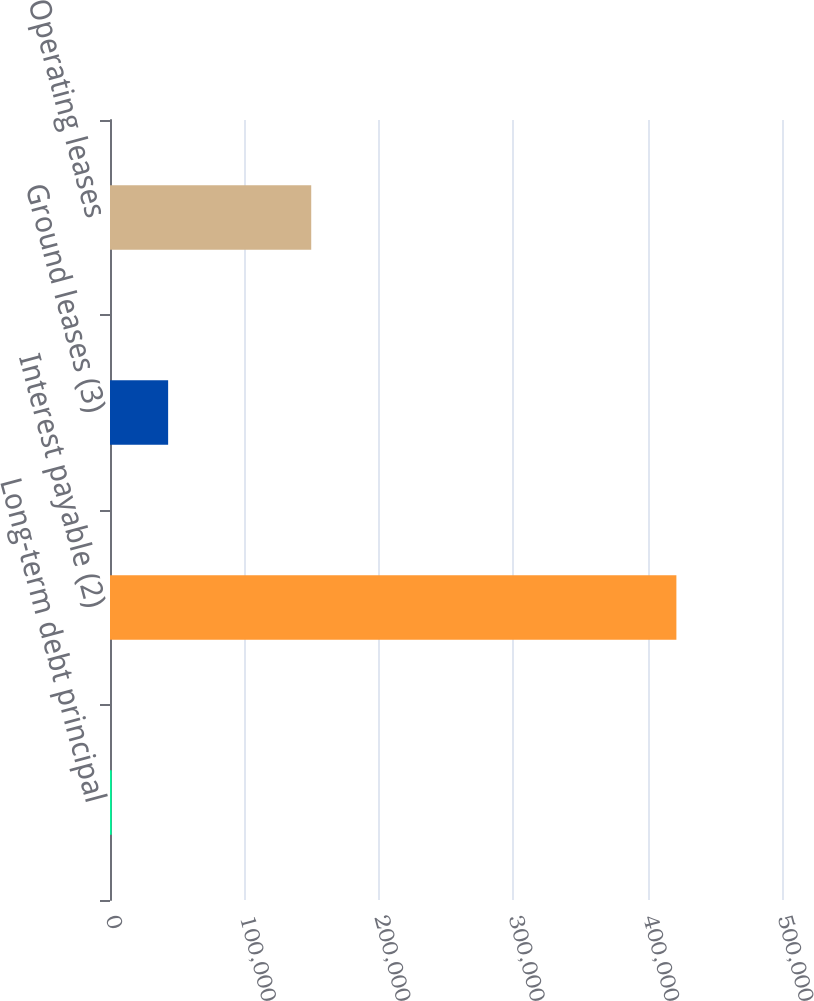Convert chart to OTSL. <chart><loc_0><loc_0><loc_500><loc_500><bar_chart><fcel>Long-term debt principal<fcel>Interest payable (2)<fcel>Ground leases (3)<fcel>Operating leases<nl><fcel>1237<fcel>421419<fcel>43255.2<fcel>149721<nl></chart> 